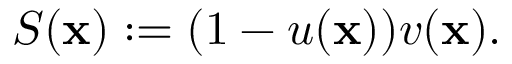<formula> <loc_0><loc_0><loc_500><loc_500>S ( \mathbf x ) \colon = ( 1 - u ( \mathbf x ) ) v ( \mathbf x ) .</formula> 